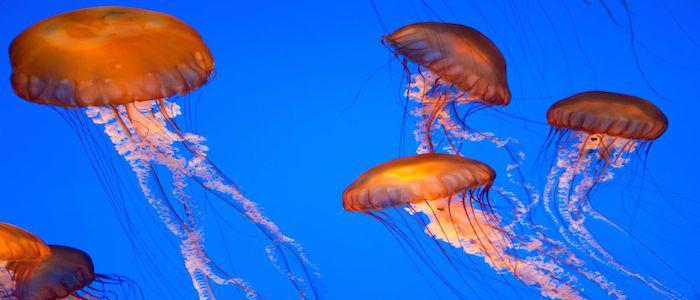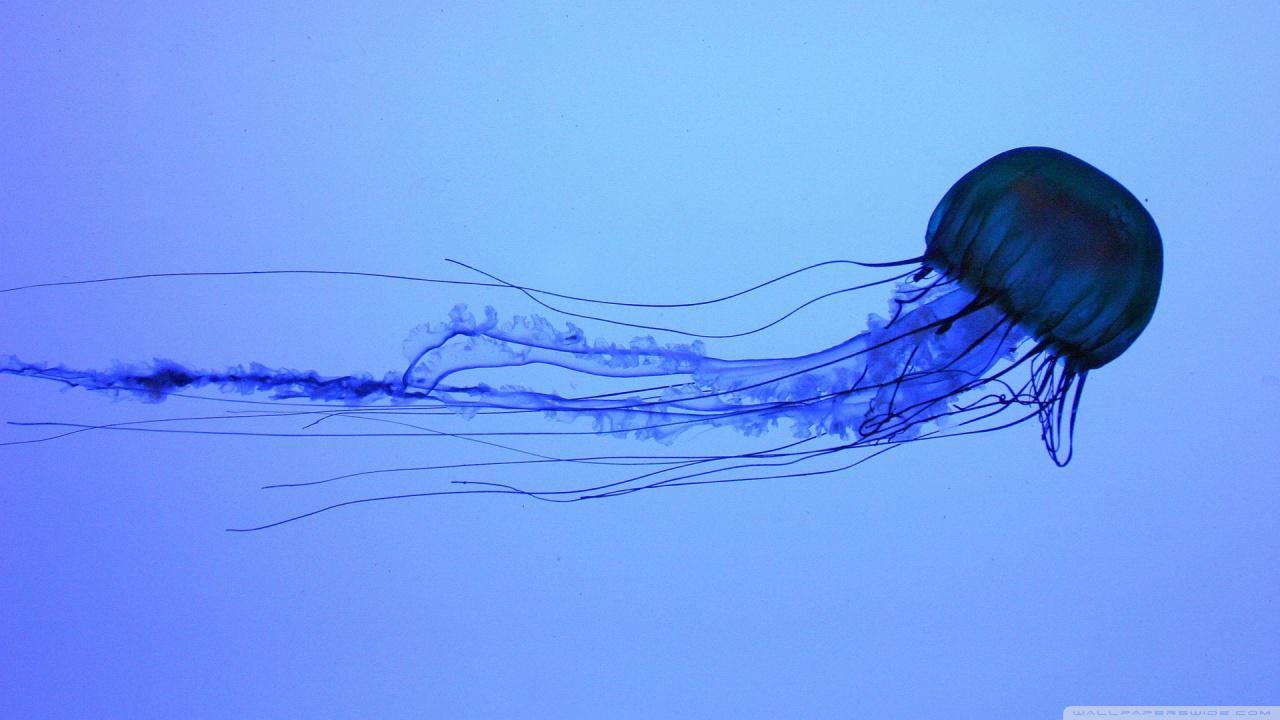The first image is the image on the left, the second image is the image on the right. Examine the images to the left and right. Is the description "in the image pair the jelly fish are facing each other" accurate? Answer yes or no. No. The first image is the image on the left, the second image is the image on the right. Assess this claim about the two images: "Exactly two orange jellyfish are swimming through the water, one of them toward the right and the other one toward the left.". Correct or not? Answer yes or no. No. 